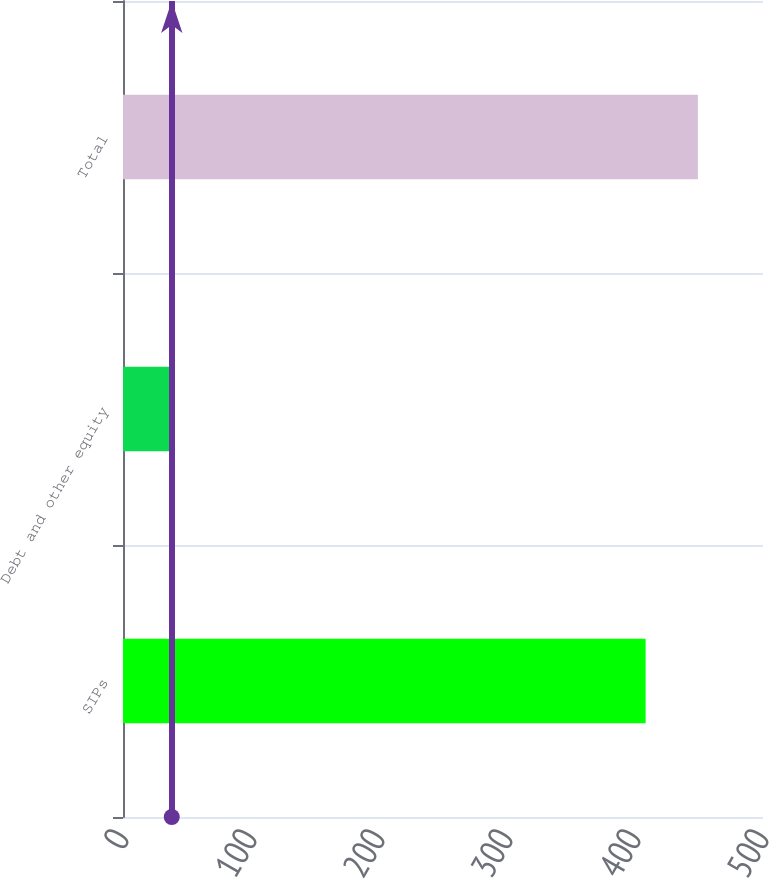Convert chart. <chart><loc_0><loc_0><loc_500><loc_500><bar_chart><fcel>SIPs<fcel>Debt and other equity<fcel>Total<nl><fcel>408.3<fcel>38.1<fcel>449.13<nl></chart> 